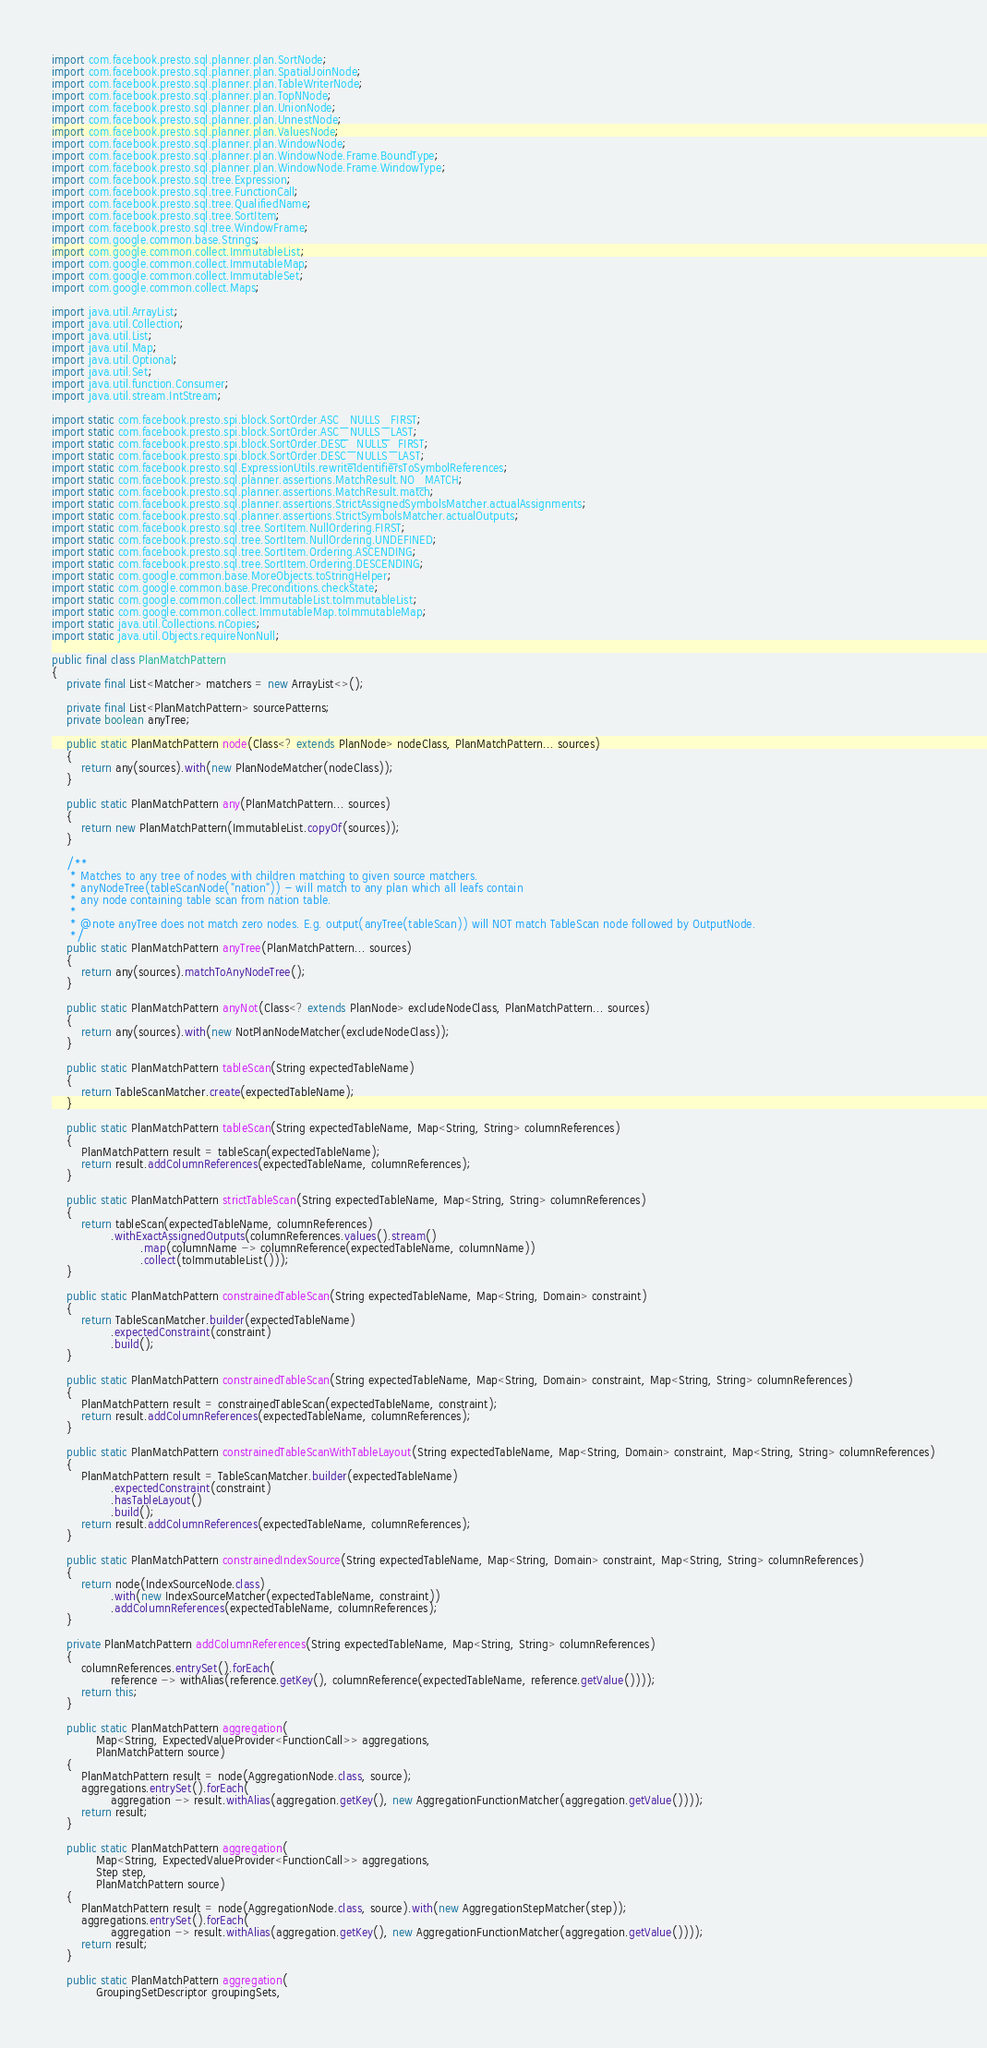<code> <loc_0><loc_0><loc_500><loc_500><_Java_>import com.facebook.presto.sql.planner.plan.SortNode;
import com.facebook.presto.sql.planner.plan.SpatialJoinNode;
import com.facebook.presto.sql.planner.plan.TableWriterNode;
import com.facebook.presto.sql.planner.plan.TopNNode;
import com.facebook.presto.sql.planner.plan.UnionNode;
import com.facebook.presto.sql.planner.plan.UnnestNode;
import com.facebook.presto.sql.planner.plan.ValuesNode;
import com.facebook.presto.sql.planner.plan.WindowNode;
import com.facebook.presto.sql.planner.plan.WindowNode.Frame.BoundType;
import com.facebook.presto.sql.planner.plan.WindowNode.Frame.WindowType;
import com.facebook.presto.sql.tree.Expression;
import com.facebook.presto.sql.tree.FunctionCall;
import com.facebook.presto.sql.tree.QualifiedName;
import com.facebook.presto.sql.tree.SortItem;
import com.facebook.presto.sql.tree.WindowFrame;
import com.google.common.base.Strings;
import com.google.common.collect.ImmutableList;
import com.google.common.collect.ImmutableMap;
import com.google.common.collect.ImmutableSet;
import com.google.common.collect.Maps;

import java.util.ArrayList;
import java.util.Collection;
import java.util.List;
import java.util.Map;
import java.util.Optional;
import java.util.Set;
import java.util.function.Consumer;
import java.util.stream.IntStream;

import static com.facebook.presto.spi.block.SortOrder.ASC_NULLS_FIRST;
import static com.facebook.presto.spi.block.SortOrder.ASC_NULLS_LAST;
import static com.facebook.presto.spi.block.SortOrder.DESC_NULLS_FIRST;
import static com.facebook.presto.spi.block.SortOrder.DESC_NULLS_LAST;
import static com.facebook.presto.sql.ExpressionUtils.rewriteIdentifiersToSymbolReferences;
import static com.facebook.presto.sql.planner.assertions.MatchResult.NO_MATCH;
import static com.facebook.presto.sql.planner.assertions.MatchResult.match;
import static com.facebook.presto.sql.planner.assertions.StrictAssignedSymbolsMatcher.actualAssignments;
import static com.facebook.presto.sql.planner.assertions.StrictSymbolsMatcher.actualOutputs;
import static com.facebook.presto.sql.tree.SortItem.NullOrdering.FIRST;
import static com.facebook.presto.sql.tree.SortItem.NullOrdering.UNDEFINED;
import static com.facebook.presto.sql.tree.SortItem.Ordering.ASCENDING;
import static com.facebook.presto.sql.tree.SortItem.Ordering.DESCENDING;
import static com.google.common.base.MoreObjects.toStringHelper;
import static com.google.common.base.Preconditions.checkState;
import static com.google.common.collect.ImmutableList.toImmutableList;
import static com.google.common.collect.ImmutableMap.toImmutableMap;
import static java.util.Collections.nCopies;
import static java.util.Objects.requireNonNull;

public final class PlanMatchPattern
{
    private final List<Matcher> matchers = new ArrayList<>();

    private final List<PlanMatchPattern> sourcePatterns;
    private boolean anyTree;

    public static PlanMatchPattern node(Class<? extends PlanNode> nodeClass, PlanMatchPattern... sources)
    {
        return any(sources).with(new PlanNodeMatcher(nodeClass));
    }

    public static PlanMatchPattern any(PlanMatchPattern... sources)
    {
        return new PlanMatchPattern(ImmutableList.copyOf(sources));
    }

    /**
     * Matches to any tree of nodes with children matching to given source matchers.
     * anyNodeTree(tableScanNode("nation")) - will match to any plan which all leafs contain
     * any node containing table scan from nation table.
     *
     * @note anyTree does not match zero nodes. E.g. output(anyTree(tableScan)) will NOT match TableScan node followed by OutputNode.
     */
    public static PlanMatchPattern anyTree(PlanMatchPattern... sources)
    {
        return any(sources).matchToAnyNodeTree();
    }

    public static PlanMatchPattern anyNot(Class<? extends PlanNode> excludeNodeClass, PlanMatchPattern... sources)
    {
        return any(sources).with(new NotPlanNodeMatcher(excludeNodeClass));
    }

    public static PlanMatchPattern tableScan(String expectedTableName)
    {
        return TableScanMatcher.create(expectedTableName);
    }

    public static PlanMatchPattern tableScan(String expectedTableName, Map<String, String> columnReferences)
    {
        PlanMatchPattern result = tableScan(expectedTableName);
        return result.addColumnReferences(expectedTableName, columnReferences);
    }

    public static PlanMatchPattern strictTableScan(String expectedTableName, Map<String, String> columnReferences)
    {
        return tableScan(expectedTableName, columnReferences)
                .withExactAssignedOutputs(columnReferences.values().stream()
                        .map(columnName -> columnReference(expectedTableName, columnName))
                        .collect(toImmutableList()));
    }

    public static PlanMatchPattern constrainedTableScan(String expectedTableName, Map<String, Domain> constraint)
    {
        return TableScanMatcher.builder(expectedTableName)
                .expectedConstraint(constraint)
                .build();
    }

    public static PlanMatchPattern constrainedTableScan(String expectedTableName, Map<String, Domain> constraint, Map<String, String> columnReferences)
    {
        PlanMatchPattern result = constrainedTableScan(expectedTableName, constraint);
        return result.addColumnReferences(expectedTableName, columnReferences);
    }

    public static PlanMatchPattern constrainedTableScanWithTableLayout(String expectedTableName, Map<String, Domain> constraint, Map<String, String> columnReferences)
    {
        PlanMatchPattern result = TableScanMatcher.builder(expectedTableName)
                .expectedConstraint(constraint)
                .hasTableLayout()
                .build();
        return result.addColumnReferences(expectedTableName, columnReferences);
    }

    public static PlanMatchPattern constrainedIndexSource(String expectedTableName, Map<String, Domain> constraint, Map<String, String> columnReferences)
    {
        return node(IndexSourceNode.class)
                .with(new IndexSourceMatcher(expectedTableName, constraint))
                .addColumnReferences(expectedTableName, columnReferences);
    }

    private PlanMatchPattern addColumnReferences(String expectedTableName, Map<String, String> columnReferences)
    {
        columnReferences.entrySet().forEach(
                reference -> withAlias(reference.getKey(), columnReference(expectedTableName, reference.getValue())));
        return this;
    }

    public static PlanMatchPattern aggregation(
            Map<String, ExpectedValueProvider<FunctionCall>> aggregations,
            PlanMatchPattern source)
    {
        PlanMatchPattern result = node(AggregationNode.class, source);
        aggregations.entrySet().forEach(
                aggregation -> result.withAlias(aggregation.getKey(), new AggregationFunctionMatcher(aggregation.getValue())));
        return result;
    }

    public static PlanMatchPattern aggregation(
            Map<String, ExpectedValueProvider<FunctionCall>> aggregations,
            Step step,
            PlanMatchPattern source)
    {
        PlanMatchPattern result = node(AggregationNode.class, source).with(new AggregationStepMatcher(step));
        aggregations.entrySet().forEach(
                aggregation -> result.withAlias(aggregation.getKey(), new AggregationFunctionMatcher(aggregation.getValue())));
        return result;
    }

    public static PlanMatchPattern aggregation(
            GroupingSetDescriptor groupingSets,</code> 